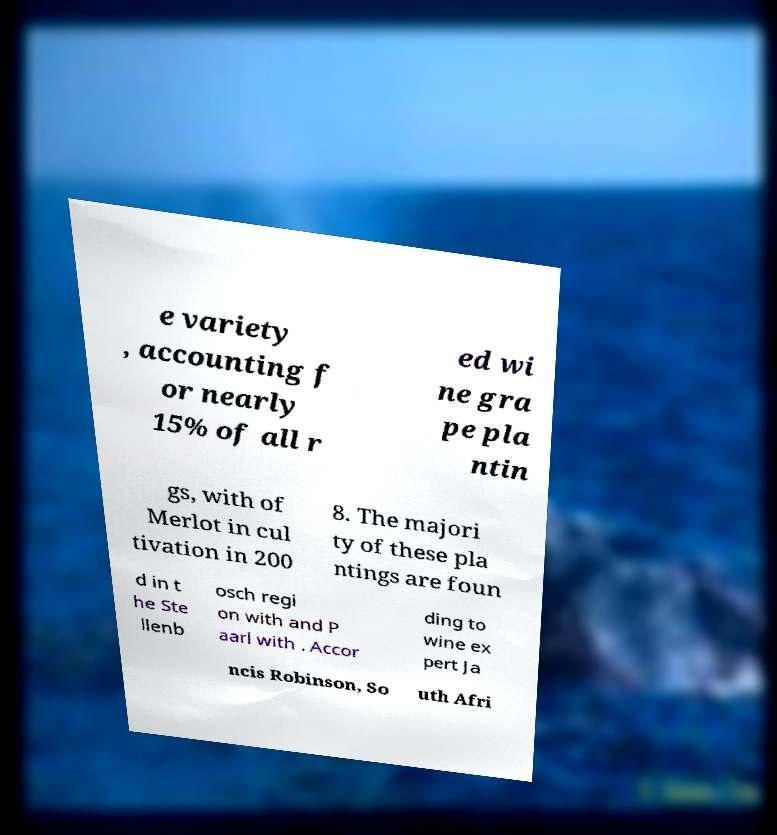Please read and relay the text visible in this image. What does it say? e variety , accounting f or nearly 15% of all r ed wi ne gra pe pla ntin gs, with of Merlot in cul tivation in 200 8. The majori ty of these pla ntings are foun d in t he Ste llenb osch regi on with and P aarl with . Accor ding to wine ex pert Ja ncis Robinson, So uth Afri 